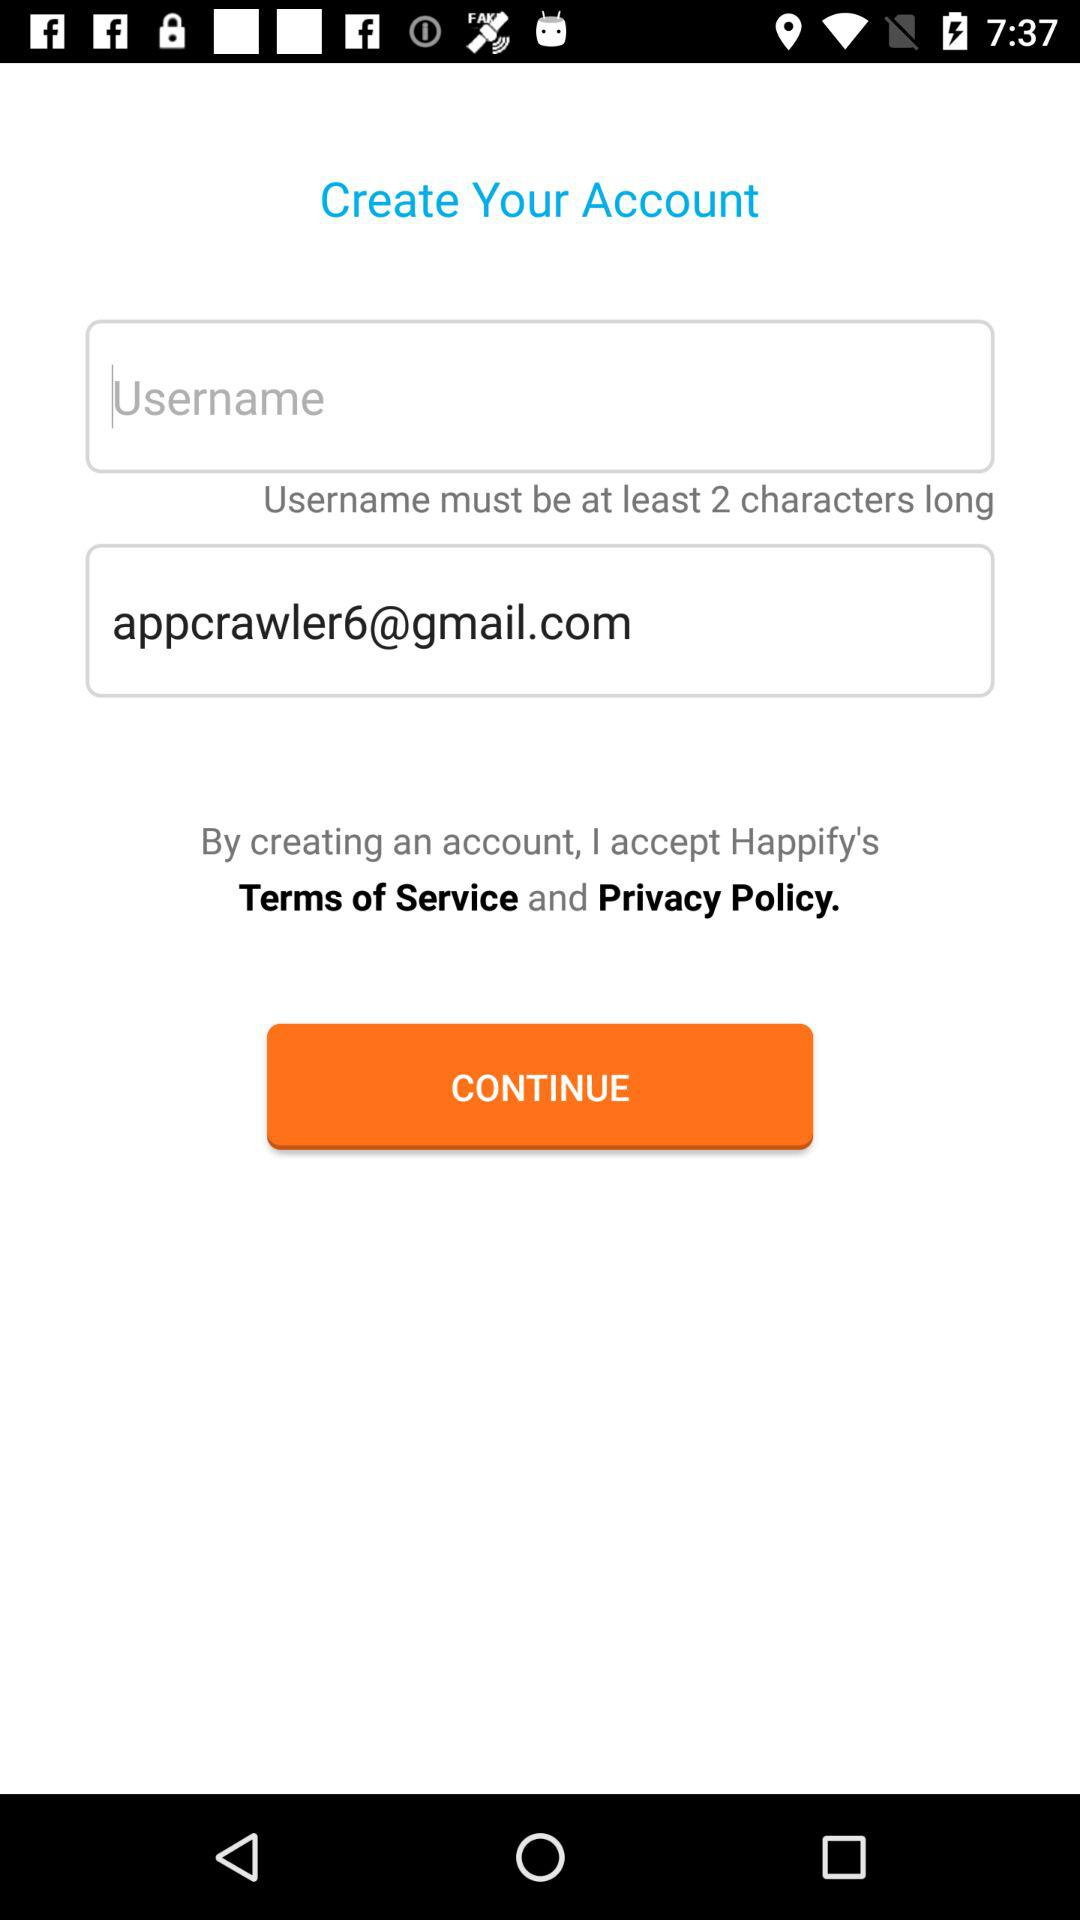What is the email address of the user? The email address of the user is appcrawler6@gmail.com. 